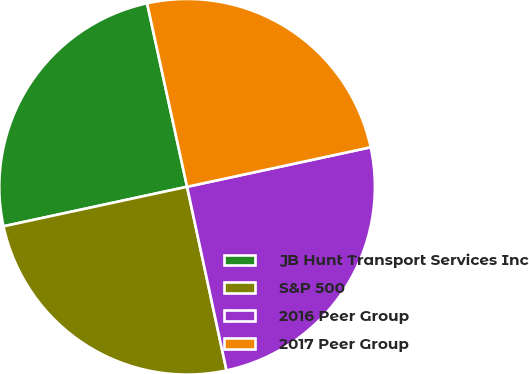<chart> <loc_0><loc_0><loc_500><loc_500><pie_chart><fcel>JB Hunt Transport Services Inc<fcel>S&P 500<fcel>2016 Peer Group<fcel>2017 Peer Group<nl><fcel>24.96%<fcel>24.99%<fcel>25.01%<fcel>25.04%<nl></chart> 